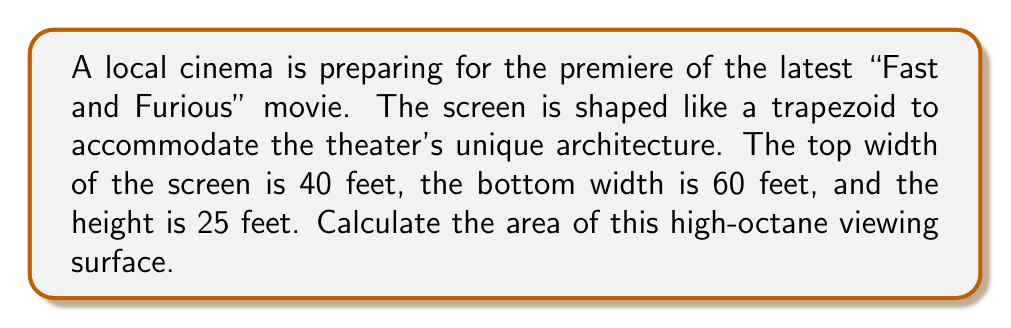Teach me how to tackle this problem. To solve this problem, we'll use the formula for the area of a trapezoid:

$$A = \frac{1}{2}(a+b)h$$

Where:
$A$ = Area of the trapezoid
$a$ = Length of one parallel side
$b$ = Length of the other parallel side
$h$ = Height of the trapezoid

Given:
$a$ = 40 feet (top width)
$b$ = 60 feet (bottom width)
$h$ = 25 feet (height)

Let's substitute these values into the formula:

$$A = \frac{1}{2}(40+60) \times 25$$

Simplifying:
$$A = \frac{1}{2}(100) \times 25$$
$$A = 50 \times 25$$
$$A = 1250$$

Therefore, the area of the movie screen is 1250 square feet.

[asy]
import geometry;

pair A = (0,0), B = (60,0), C = (50,25), D = (10,25);
draw(A--B--C--D--cycle);
draw(A--C,dashed);
draw(B--D,dashed);

label("60 ft", (30,0), S);
label("40 ft", (30,25), N);
label("25 ft", (60,12.5), E);

dot("A", A, SW);
dot("B", B, SE);
dot("C", C, NE);
dot("D", D, NW);
[/asy]
Answer: 1250 sq ft 